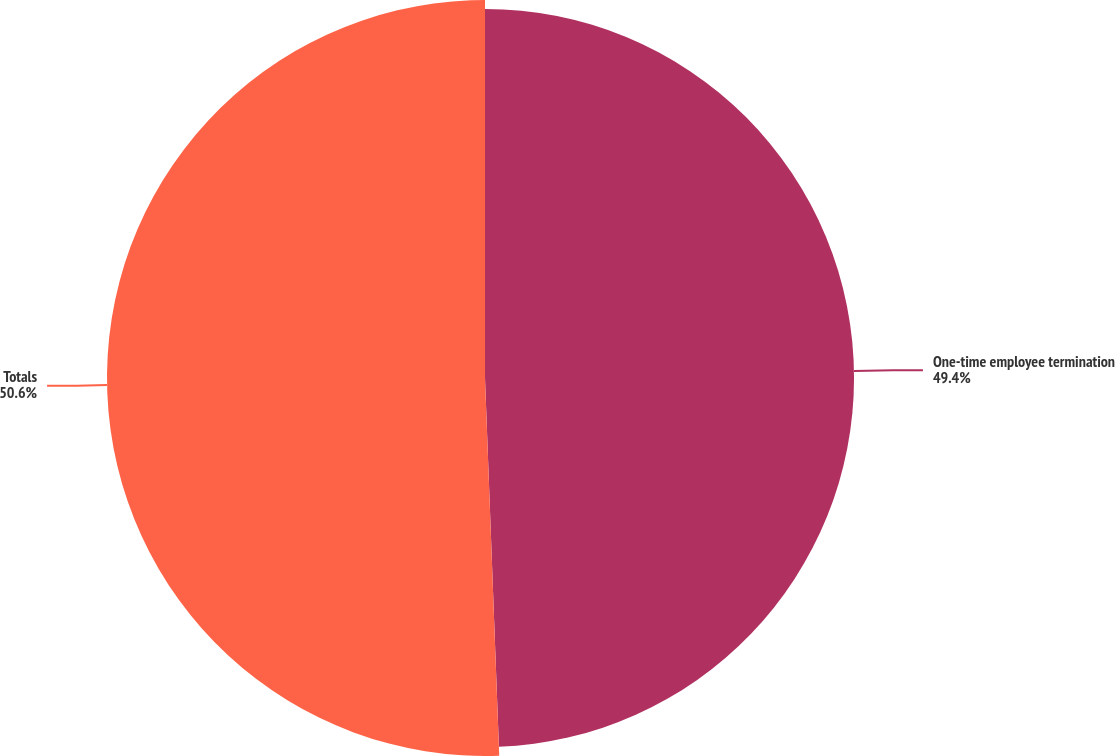Convert chart to OTSL. <chart><loc_0><loc_0><loc_500><loc_500><pie_chart><fcel>One-time employee termination<fcel>Totals<nl><fcel>49.4%<fcel>50.6%<nl></chart> 